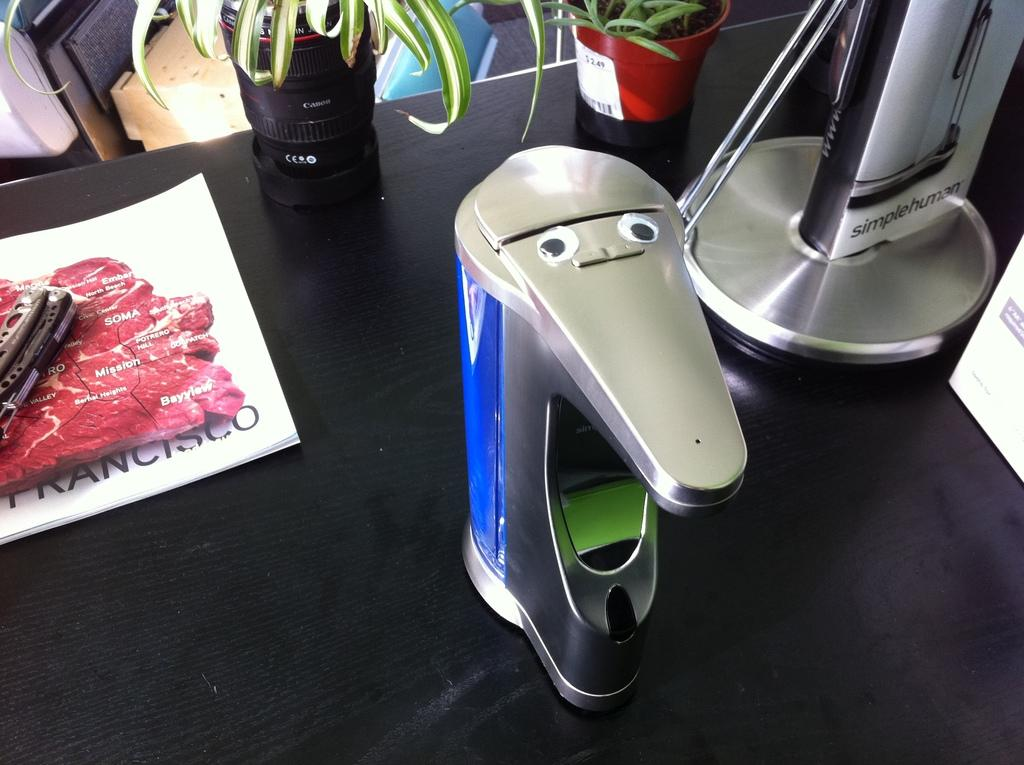<image>
Give a short and clear explanation of the subsequent image. A single serve coffee maker has googly eyes and sits on a desk by a piece of paper showing the word Francisco. 